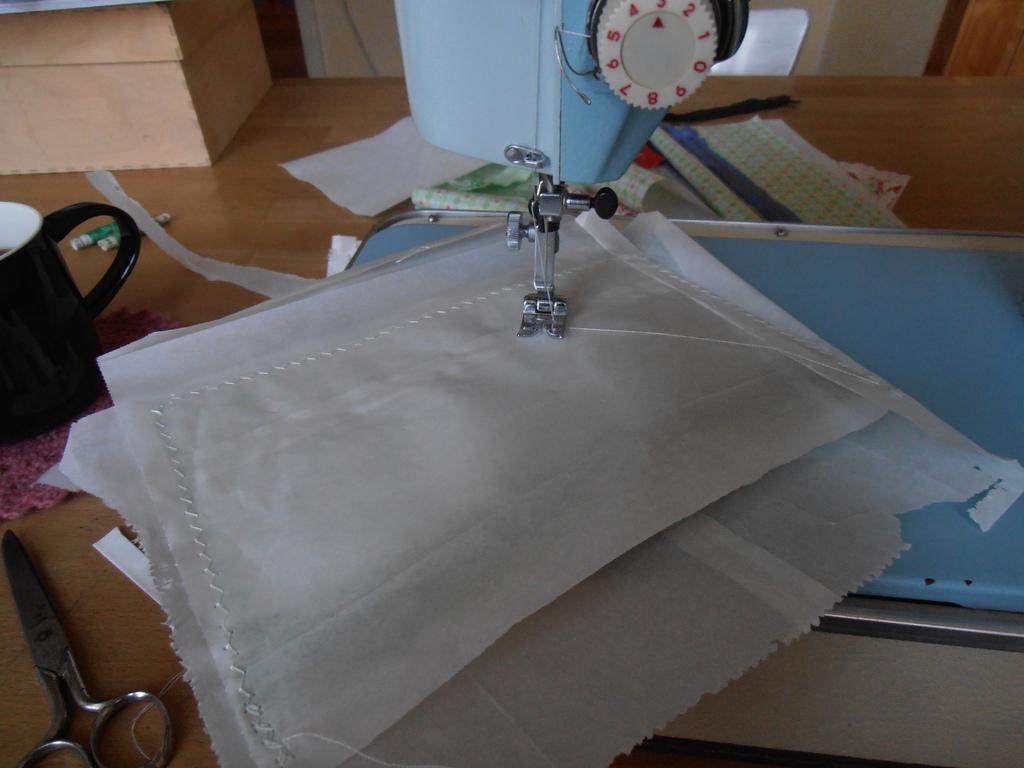Can you describe this image briefly? In this picture I can see a sewing machine. I can see papers, scissors, cup, thread rolls and some other objects on the table. 